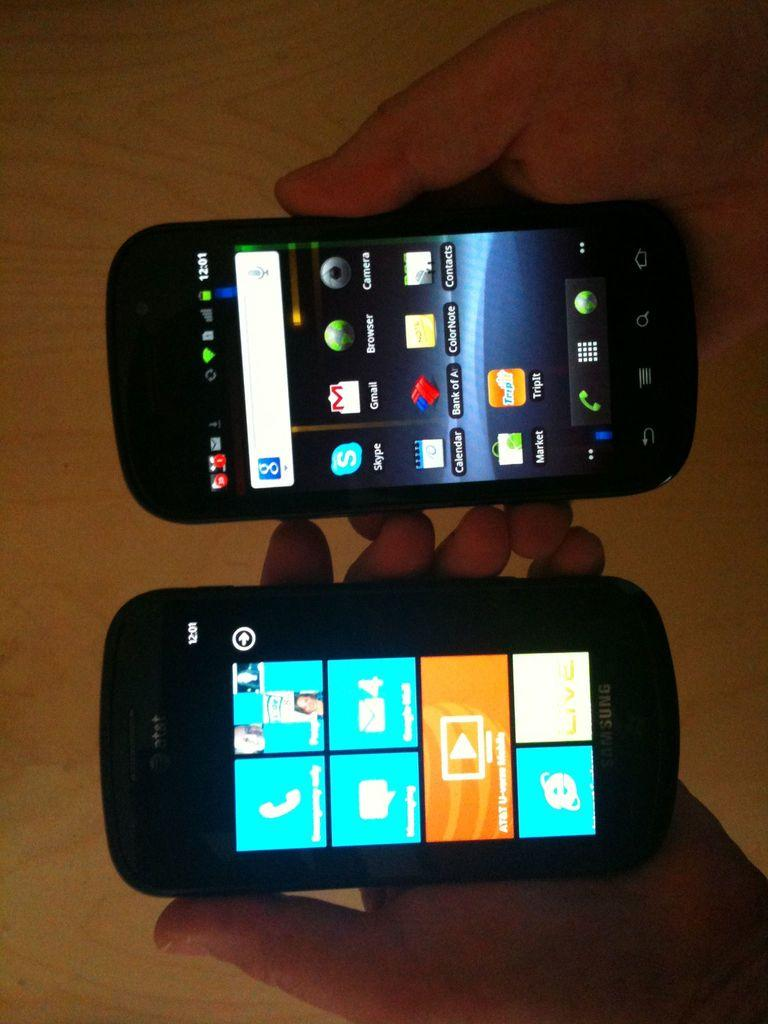<image>
Write a terse but informative summary of the picture. The phone has many apps including one named Skype.. 